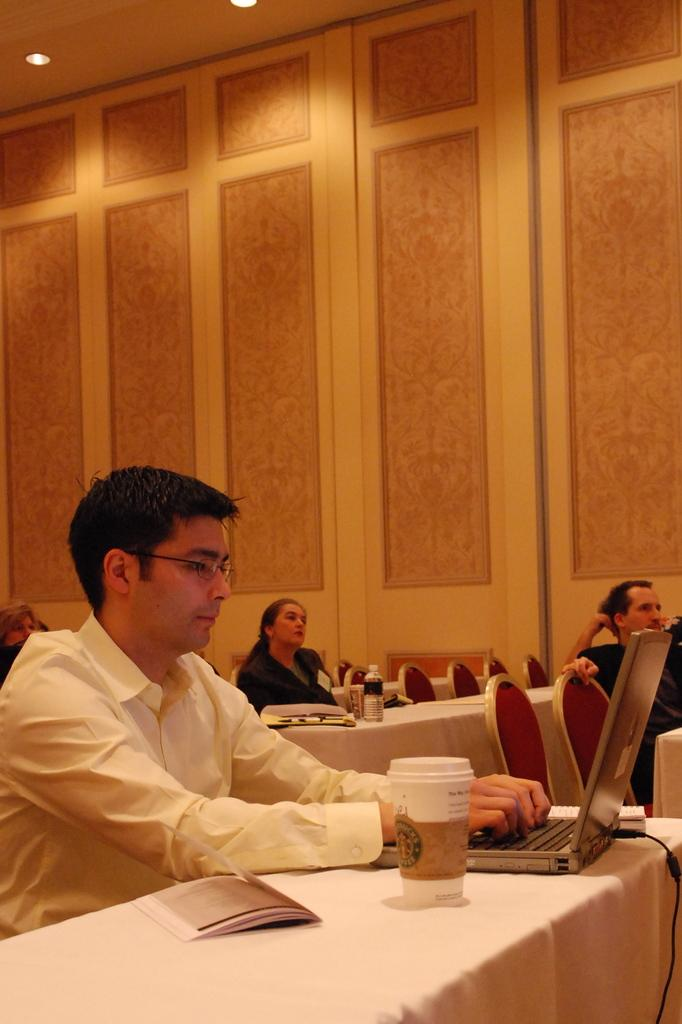What are the people in the image doing? There are persons sitting on chairs in the image. What objects are present in the image besides the chairs? There are tables, a laptop, and a bottle visible in the image. What can be seen in the background of the image? There is a wall in the background of the image. What type of tooth is visible in the image? There is no tooth present in the image. Is there a cannon visible in the image? No, there is no cannon present in the image. 